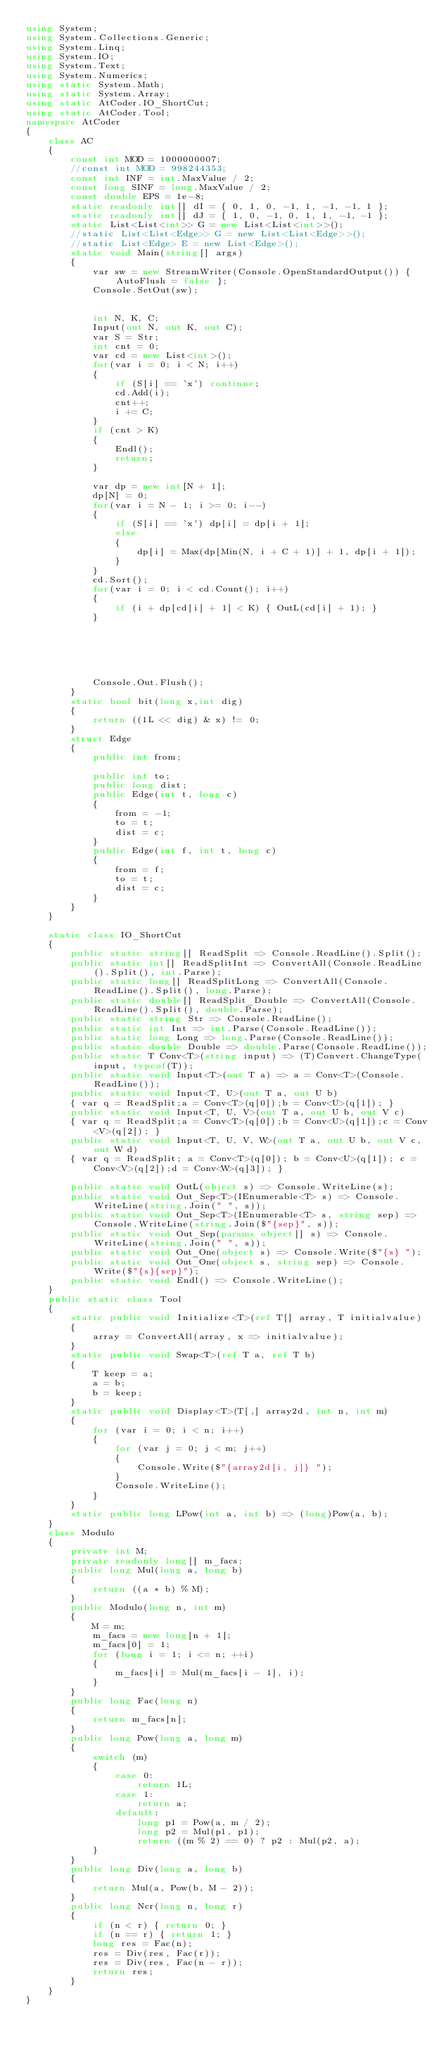<code> <loc_0><loc_0><loc_500><loc_500><_C#_>using System;
using System.Collections.Generic;
using System.Linq;
using System.IO;
using System.Text;
using System.Numerics;
using static System.Math;
using static System.Array;
using static AtCoder.IO_ShortCut;
using static AtCoder.Tool;
namespace AtCoder
{
    class AC
    {
        const int MOD = 1000000007;
        //const int MOD = 998244353;
        const int INF = int.MaxValue / 2;
        const long SINF = long.MaxValue / 2;
        const double EPS = 1e-8;
        static readonly int[] dI = { 0, 1, 0, -1, 1, -1, -1, 1 };
        static readonly int[] dJ = { 1, 0, -1, 0, 1, 1, -1, -1 };
        static List<List<int>> G = new List<List<int>>();
        //static List<List<Edge>> G = new List<List<Edge>>();
        //static List<Edge> E = new List<Edge>();
        static void Main(string[] args)
        {
            var sw = new StreamWriter(Console.OpenStandardOutput()) { AutoFlush = false };
            Console.SetOut(sw);


            int N, K, C;
            Input(out N, out K, out C);
            var S = Str;
            int cnt = 0;
            var cd = new List<int>();
            for(var i = 0; i < N; i++)
            {
                if (S[i] == 'x') continue;
                cd.Add(i);
                cnt++;
                i += C;
            }
            if (cnt > K)
            {
                Endl();
                return;
            }

            var dp = new int[N + 1];
            dp[N] = 0;
            for(var i = N - 1; i >= 0; i--)
            {
                if (S[i] == 'x') dp[i] = dp[i + 1];
                else
                {
                    dp[i] = Max(dp[Min(N, i + C + 1)] + 1, dp[i + 1]);
                }
            }
            cd.Sort();
            for(var i = 0; i < cd.Count(); i++)
            {
                if (i + dp[cd[i] + 1] < K) { OutL(cd[i] + 1); }
            }






            Console.Out.Flush();
        }
        static bool bit(long x,int dig)
        {
            return ((1L << dig) & x) != 0;
        }
        struct Edge
        {
            public int from;

            public int to;
            public long dist;
            public Edge(int t, long c)
            {
                from = -1;
                to = t;
                dist = c;
            }
            public Edge(int f, int t, long c)
            {
                from = f;
                to = t;
                dist = c;
            }
        }
    }
    
    static class IO_ShortCut
    {
        public static string[] ReadSplit => Console.ReadLine().Split();
        public static int[] ReadSplitInt => ConvertAll(Console.ReadLine().Split(), int.Parse);
        public static long[] ReadSplitLong => ConvertAll(Console.ReadLine().Split(), long.Parse);
        public static double[] ReadSplit_Double => ConvertAll(Console.ReadLine().Split(), double.Parse);
        public static string Str => Console.ReadLine();
        public static int Int => int.Parse(Console.ReadLine());
        public static long Long => long.Parse(Console.ReadLine());
        public static double Double => double.Parse(Console.ReadLine());
        public static T Conv<T>(string input) => (T)Convert.ChangeType(input, typeof(T));
        public static void Input<T>(out T a) => a = Conv<T>(Console.ReadLine());
        public static void Input<T, U>(out T a, out U b)
        { var q = ReadSplit;a = Conv<T>(q[0]);b = Conv<U>(q[1]); }
        public static void Input<T, U, V>(out T a, out U b, out V c)
        { var q = ReadSplit;a = Conv<T>(q[0]);b = Conv<U>(q[1]);c = Conv<V>(q[2]); }
        public static void Input<T, U, V, W>(out T a, out U b, out V c, out W d)
        { var q = ReadSplit; a = Conv<T>(q[0]); b = Conv<U>(q[1]); c = Conv<V>(q[2]);d = Conv<W>(q[3]); }

        public static void OutL(object s) => Console.WriteLine(s);
        public static void Out_Sep<T>(IEnumerable<T> s) => Console.WriteLine(string.Join(" ", s));
        public static void Out_Sep<T>(IEnumerable<T> s, string sep) => Console.WriteLine(string.Join($"{sep}", s));
        public static void Out_Sep(params object[] s) => Console.WriteLine(string.Join(" ", s));
        public static void Out_One(object s) => Console.Write($"{s} ");
        public static void Out_One(object s, string sep) => Console.Write($"{s}{sep}");
        public static void Endl() => Console.WriteLine();
    }
    public static class Tool
    {
        static public void Initialize<T>(ref T[] array, T initialvalue)
        {
            array = ConvertAll(array, x => initialvalue);
        }
        static public void Swap<T>(ref T a, ref T b)
        {
            T keep = a;
            a = b;
            b = keep;
        }
        static public void Display<T>(T[,] array2d, int n, int m)
        {
            for (var i = 0; i < n; i++)
            {
                for (var j = 0; j < m; j++)
                {
                    Console.Write($"{array2d[i, j]} ");
                }
                Console.WriteLine();
            }
        }
        static public long LPow(int a, int b) => (long)Pow(a, b);
    }
    class Modulo
    {
        private int M;
        private readonly long[] m_facs;
        public long Mul(long a, long b)
        {
            return ((a * b) % M);
        }
        public Modulo(long n, int m)
        {
            M = m;
            m_facs = new long[n + 1];
            m_facs[0] = 1;
            for (long i = 1; i <= n; ++i)
            {
                m_facs[i] = Mul(m_facs[i - 1], i);
            }
        }
        public long Fac(long n)
        {
            return m_facs[n];
        }
        public long Pow(long a, long m)
        {
            switch (m)
            {
                case 0:
                    return 1L;
                case 1:
                    return a;
                default:
                    long p1 = Pow(a, m / 2);
                    long p2 = Mul(p1, p1);
                    return ((m % 2) == 0) ? p2 : Mul(p2, a);
            }
        }
        public long Div(long a, long b)
        {
            return Mul(a, Pow(b, M - 2));
        }
        public long Ncr(long n, long r)
        {
            if (n < r) { return 0; }
            if (n == r) { return 1; }
            long res = Fac(n);
            res = Div(res, Fac(r));
            res = Div(res, Fac(n - r));
            return res;
        }
    }
}
</code> 